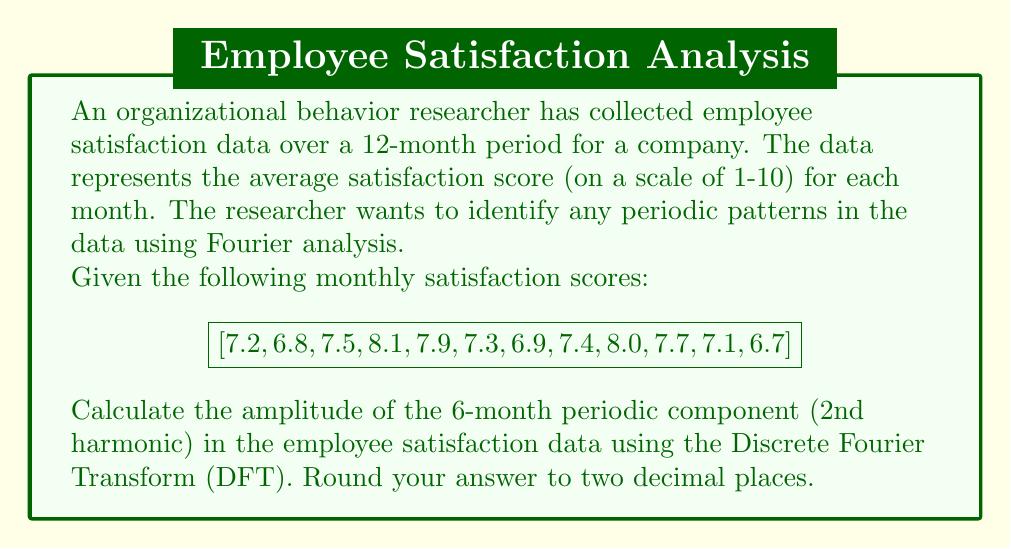Can you answer this question? To solve this problem, we'll follow these steps:

1) First, we need to calculate the Discrete Fourier Transform (DFT) of the data. The DFT is given by:

   $$X_k = \sum_{n=0}^{N-1} x_n e^{-i2\pi kn/N}$$

   where $N$ is the number of data points (12 in this case), $x_n$ are the data points, and $k$ is the frequency index.

2) For the 6-month periodic component (2nd harmonic), we need to calculate $X_2$:

   $$X_2 = \sum_{n=0}^{11} x_n e^{-i2\pi 2n/12}$$

3) Expanding this:

   $$X_2 = 7.2e^{-i\pi/3} + 6.8e^{-i2\pi/3} + 7.5e^{-i\pi} + 8.1e^{-i4\pi/3} + 7.9e^{-i5\pi/3} + 7.3e^{-i2\pi} + \\
   6.9e^{-i7\pi/3} + 7.4e^{-i8\pi/3} + 8.0e^{-i3\pi} + 7.7e^{-i10\pi/3} + 7.1e^{-i11\pi/3} + 6.7e^{-i4\pi}$$

4) Simplifying the complex exponentials:

   $$X_2 = (7.2 - 6.8 - 7.5 + 8.1 + 7.9 - 7.3 - 6.9 + 7.4 + 8.0 - 7.7 - 7.1 + 6.7) + \\
   i(\sqrt{3}/2)(7.2 + 6.8 - 8.1 - 7.9 + 6.9 + 7.4 - 7.7 - 7.1)$$

5) Calculating the real and imaginary parts:

   Real part = 2.0
   Imaginary part = -0.7794

6) The amplitude is the magnitude of this complex number:

   $$|X_2| = \sqrt{(2.0)^2 + (-0.7794)^2} = 2.1447$$

7) To get the actual amplitude, we need to divide this by N/2 = 6:

   Amplitude = 2.1447 / 6 = 0.3574

8) Rounding to two decimal places: 0.36
Answer: 0.36 